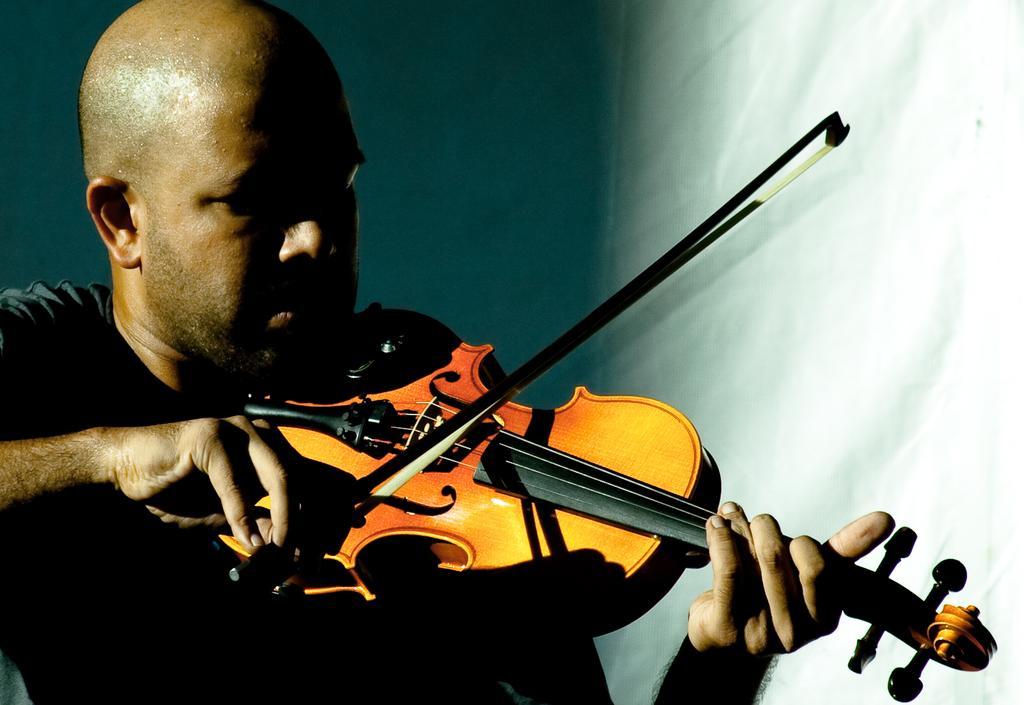Who is the main subject in the image? There is a man in the image. What is the man wearing? The man is wearing a black t-shirt. What is the man doing in the image? The man is playing a violin. What material is the violin made of? The violin is made of wood. What can be seen behind the man in the image? There is a wall behind the man. Does the man have a sister playing the violin with him in the image? There is no indication of a sister or any other person playing the violin in the image; it only features the man playing the violin. 